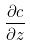Convert formula to latex. <formula><loc_0><loc_0><loc_500><loc_500>\frac { \partial c } { \partial z }</formula> 